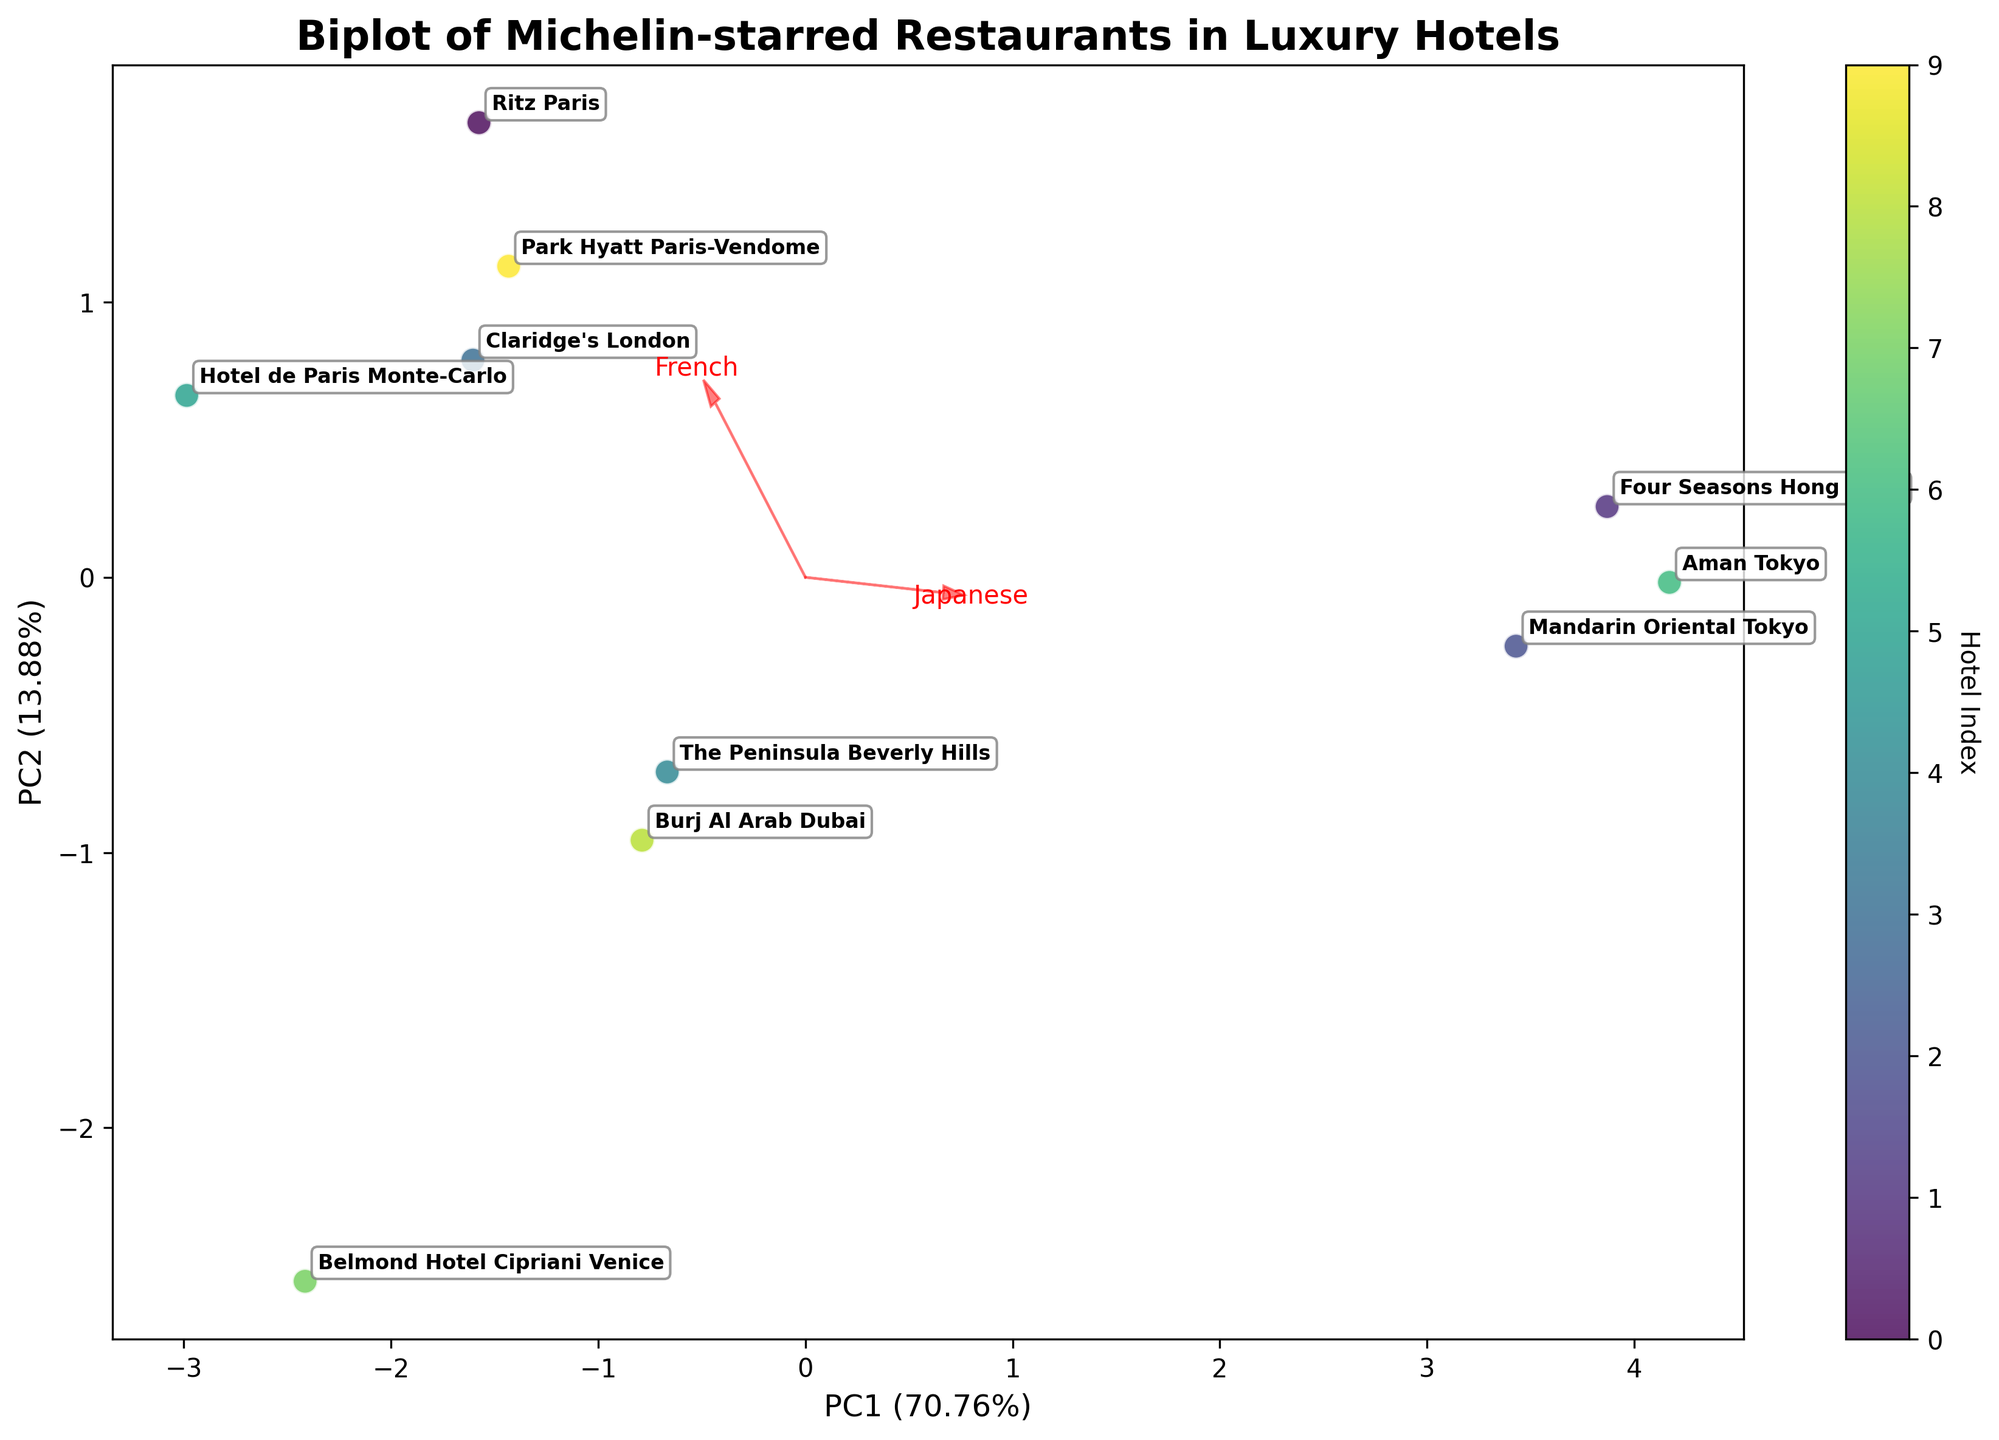what's the title of the plot? The title of a plot is usually located at the top. In this biplot, the text at the top reads: "Biplot of Michelin-starred Restaurants in Luxury Hotels."
Answer: Biplot of Michelin-starred Restaurants in Luxury Hotels how many luxury hotels are plotted in this figure? To count the number of luxury hotels, we can refer to the number of data points labeled on the biplot. Each hotel is marked with its name in the figure. There are ten unique names visible on the plot.
Answer: 10 which luxury hotel is most closely associated with Japanese cuisine based on the plot? To determine the luxury hotel's association with cuisine type, we can look at where the hotel points are located in relation to the cuisine arrows. The hotel closest to the Japanese cuisine vector is "Aman Tokyo."
Answer: Aman Tokyo which cuisine type is the furthest from the origin in the biplot? The distance from the origin to a point indicates its variance explained by the principal components. By observing the arrows representing different cuisines, the one extending furthest from the origin is "French."
Answer: French do "Four Seasons Hong Kong" and "Mandarin Oriental Tokyo" have similar cuisine distributions? To compare similarities, check the relative positions of "Four Seasons Hong Kong" and "Mandarin Oriental Tokyo" data points. They are located in different parts of the biplot, suggesting they have distinct cuisine types.
Answer: No does the Ritz Paris have a high association with Modern European cuisine? Look at the Ritz Paris point's proximity to the “Modern European” vector. The point is not very close, indicating it does not have a high association with Modern European cuisine.
Answer: No which hotel shows a strong association with Chinese cuisine? Determine the point closest to the Chinese cuisine vector. "Four Seasons Hong Kong" is closest to the Chinese cuisine arrow, indicating a strong association.
Answer: Four Seasons Hong Kong describe the key feature of the PC1 axis in this biplot. The PC1 axis accounts for the largest portion of variance in the data. The axis label indicates it explains a certain percentage of variance. To interpret, consider which arrows (cuisines) have the longest projections onto this axis.
Answer: Explains the most variance which hotel is placed furthest apart from others on the biplot? The point located farthest from the centroid or other points signifies it has a unique cuisine distribution. Noticeably, "Hotel de Paris Monte-Carlo" seems separated from many hotels based on its location.
Answer: Hotel de Paris Monte-Carlo 